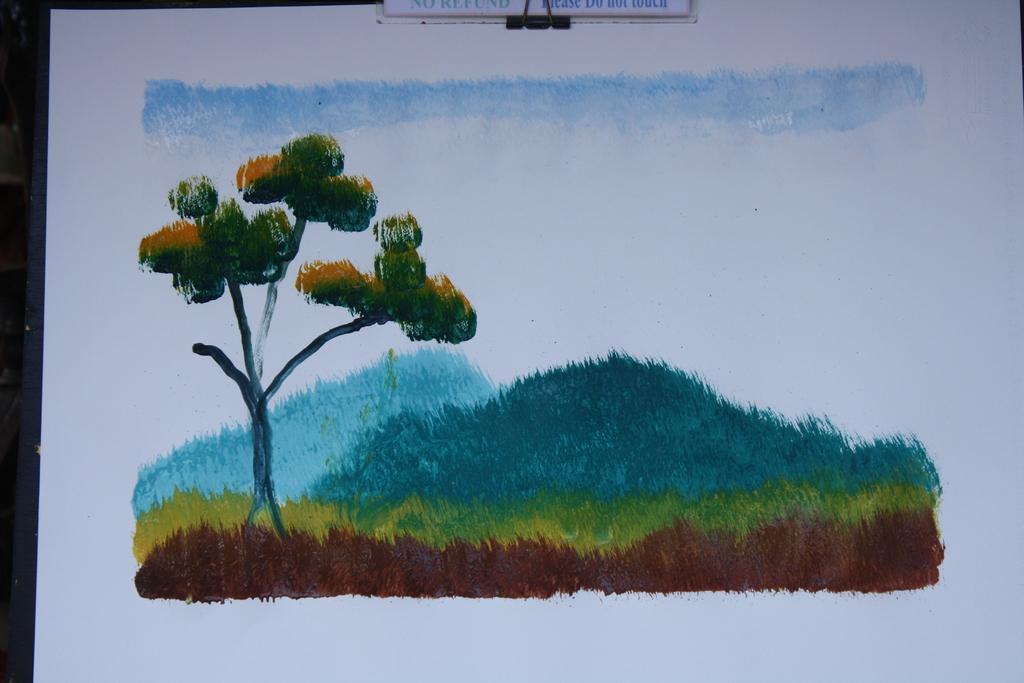Describe this image in one or two sentences. In this image I can see the painting on a paper in which I can see the grass, a tree and the sky. 